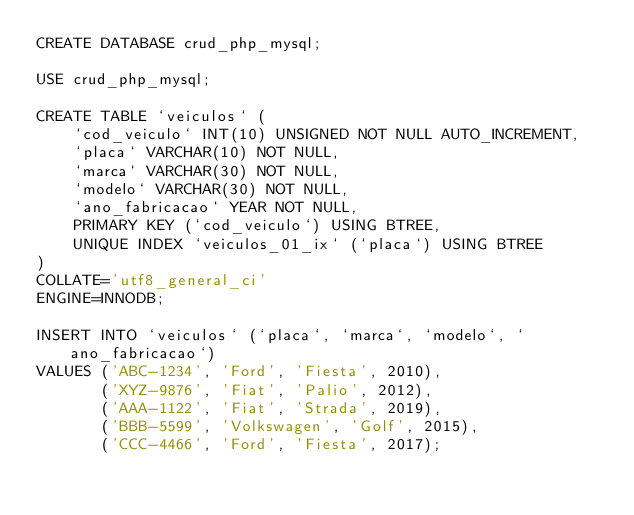<code> <loc_0><loc_0><loc_500><loc_500><_SQL_>CREATE DATABASE crud_php_mysql;

USE crud_php_mysql;

CREATE TABLE `veiculos` (
	`cod_veiculo` INT(10) UNSIGNED NOT NULL AUTO_INCREMENT,
	`placa` VARCHAR(10) NOT NULL,
	`marca` VARCHAR(30) NOT NULL,
	`modelo` VARCHAR(30) NOT NULL,
	`ano_fabricacao` YEAR NOT NULL,
	PRIMARY KEY (`cod_veiculo`) USING BTREE,
	UNIQUE INDEX `veiculos_01_ix` (`placa`) USING BTREE
)
COLLATE='utf8_general_ci'
ENGINE=INNODB;

INSERT INTO `veiculos` (`placa`, `marca`, `modelo`, `ano_fabricacao`)
VALUES ('ABC-1234', 'Ford', 'Fiesta', 2010),
       ('XYZ-9876', 'Fiat', 'Palio', 2012),
	   ('AAA-1122', 'Fiat', 'Strada', 2019),
	   ('BBB-5599', 'Volkswagen', 'Golf', 2015),
	   ('CCC-4466', 'Ford', 'Fiesta', 2017);</code> 